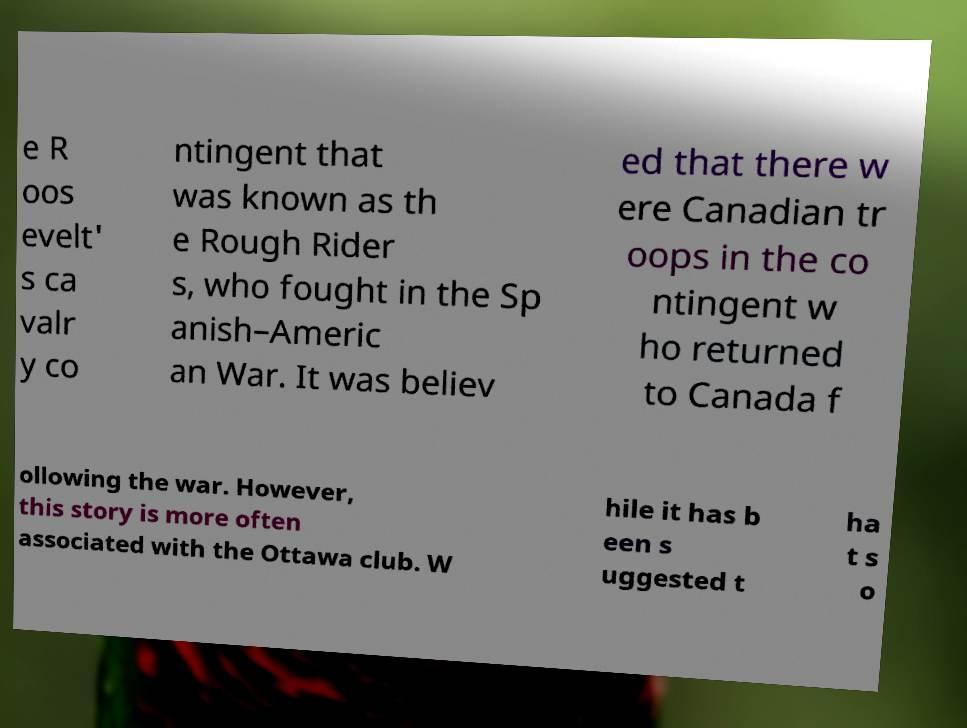Could you extract and type out the text from this image? e R oos evelt' s ca valr y co ntingent that was known as th e Rough Rider s, who fought in the Sp anish–Americ an War. It was believ ed that there w ere Canadian tr oops in the co ntingent w ho returned to Canada f ollowing the war. However, this story is more often associated with the Ottawa club. W hile it has b een s uggested t ha t s o 